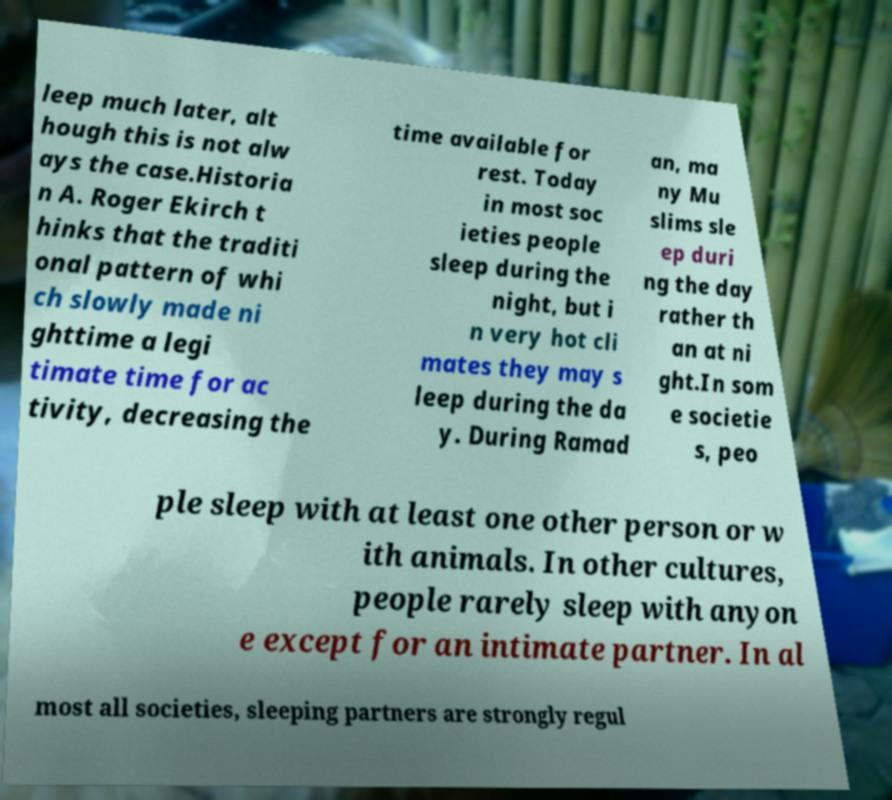For documentation purposes, I need the text within this image transcribed. Could you provide that? leep much later, alt hough this is not alw ays the case.Historia n A. Roger Ekirch t hinks that the traditi onal pattern of whi ch slowly made ni ghttime a legi timate time for ac tivity, decreasing the time available for rest. Today in most soc ieties people sleep during the night, but i n very hot cli mates they may s leep during the da y. During Ramad an, ma ny Mu slims sle ep duri ng the day rather th an at ni ght.In som e societie s, peo ple sleep with at least one other person or w ith animals. In other cultures, people rarely sleep with anyon e except for an intimate partner. In al most all societies, sleeping partners are strongly regul 